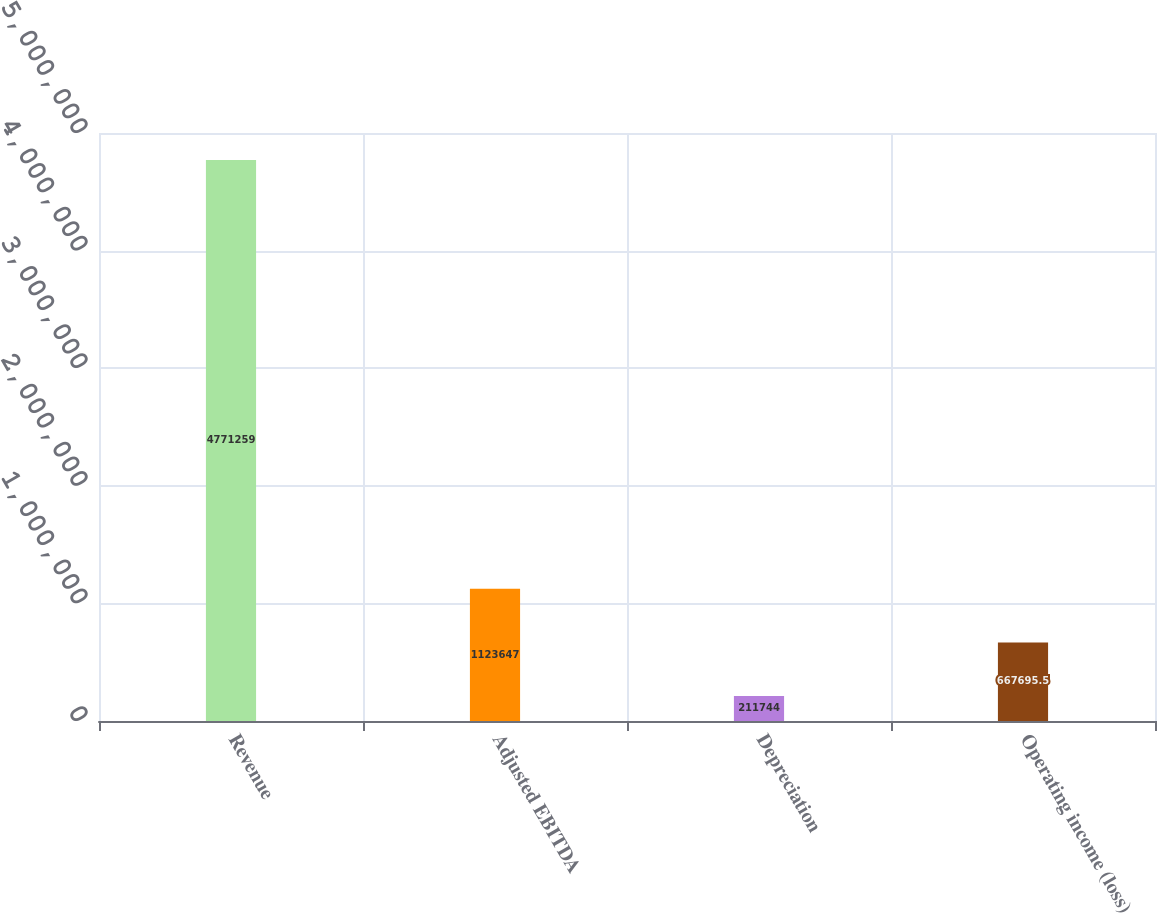Convert chart to OTSL. <chart><loc_0><loc_0><loc_500><loc_500><bar_chart><fcel>Revenue<fcel>Adjusted EBITDA<fcel>Depreciation<fcel>Operating income (loss)<nl><fcel>4.77126e+06<fcel>1.12365e+06<fcel>211744<fcel>667696<nl></chart> 